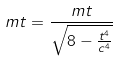Convert formula to latex. <formula><loc_0><loc_0><loc_500><loc_500>m t = \frac { m t } { \sqrt { 8 - \frac { t ^ { 4 } } { c ^ { 4 } } } }</formula> 